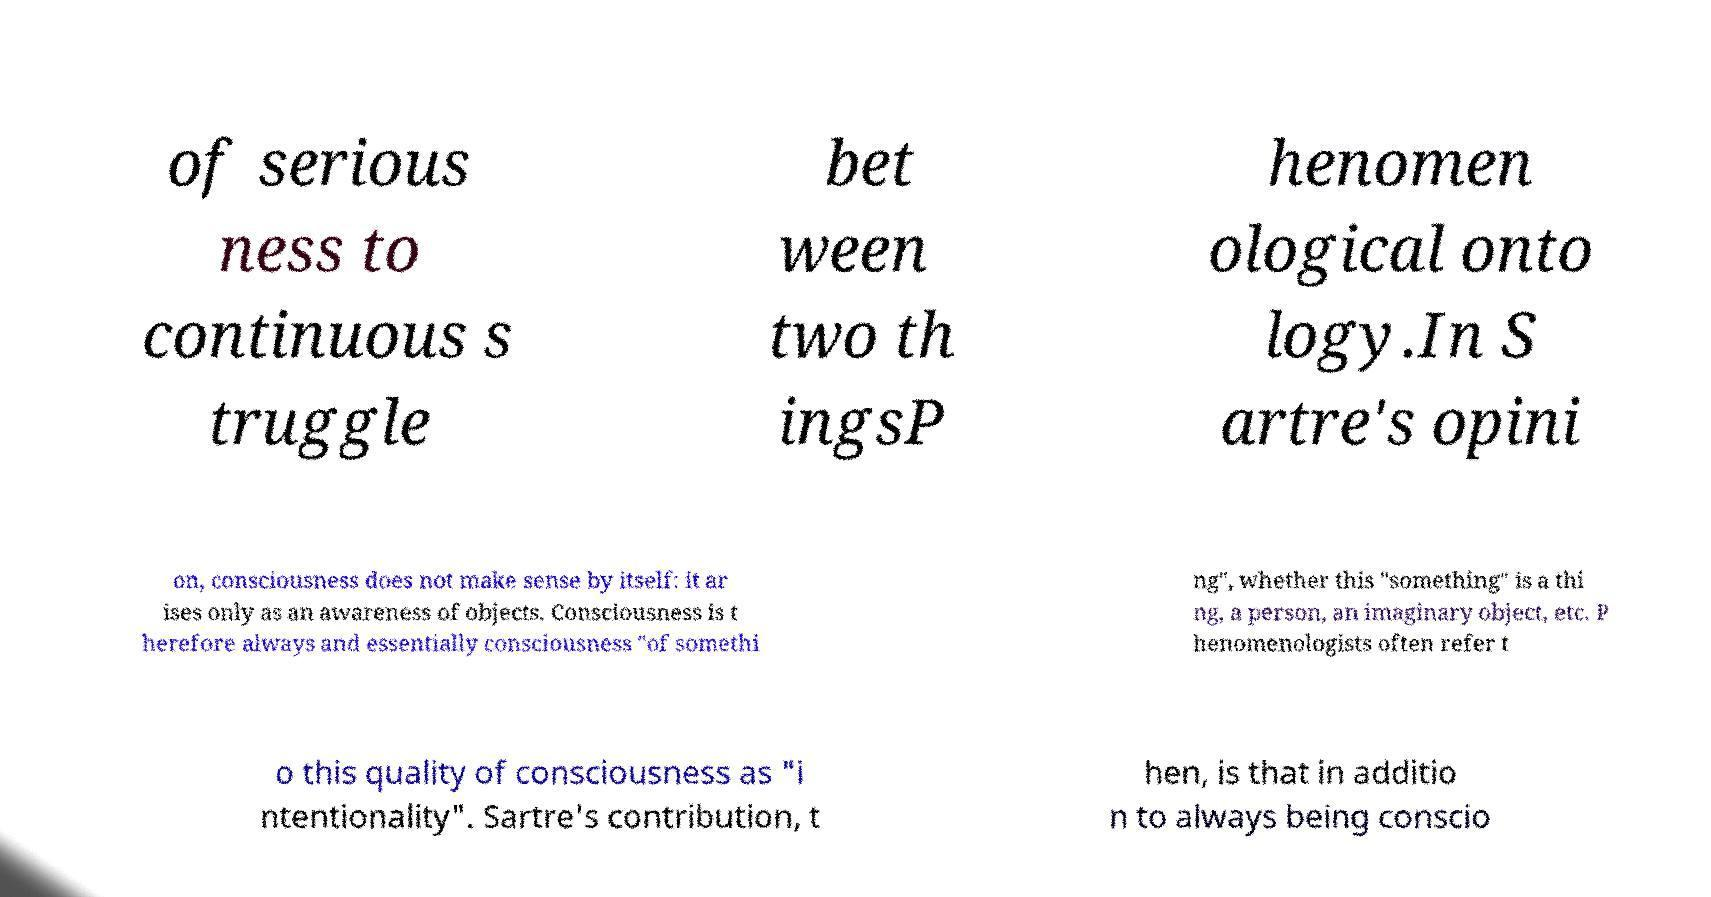For documentation purposes, I need the text within this image transcribed. Could you provide that? of serious ness to continuous s truggle bet ween two th ingsP henomen ological onto logy.In S artre's opini on, consciousness does not make sense by itself: it ar ises only as an awareness of objects. Consciousness is t herefore always and essentially consciousness "of somethi ng", whether this "something" is a thi ng, a person, an imaginary object, etc. P henomenologists often refer t o this quality of consciousness as "i ntentionality". Sartre's contribution, t hen, is that in additio n to always being conscio 